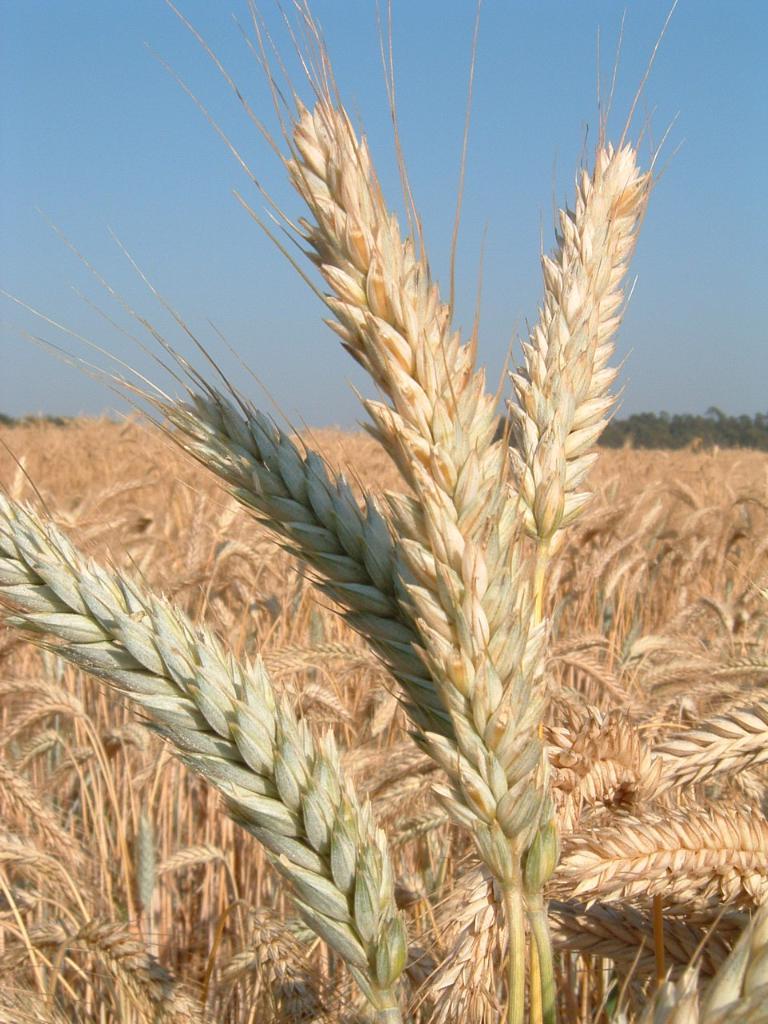Can you describe this image briefly? In this image I can see grains plants in the front. In the background I can see number of trees and the sky. 